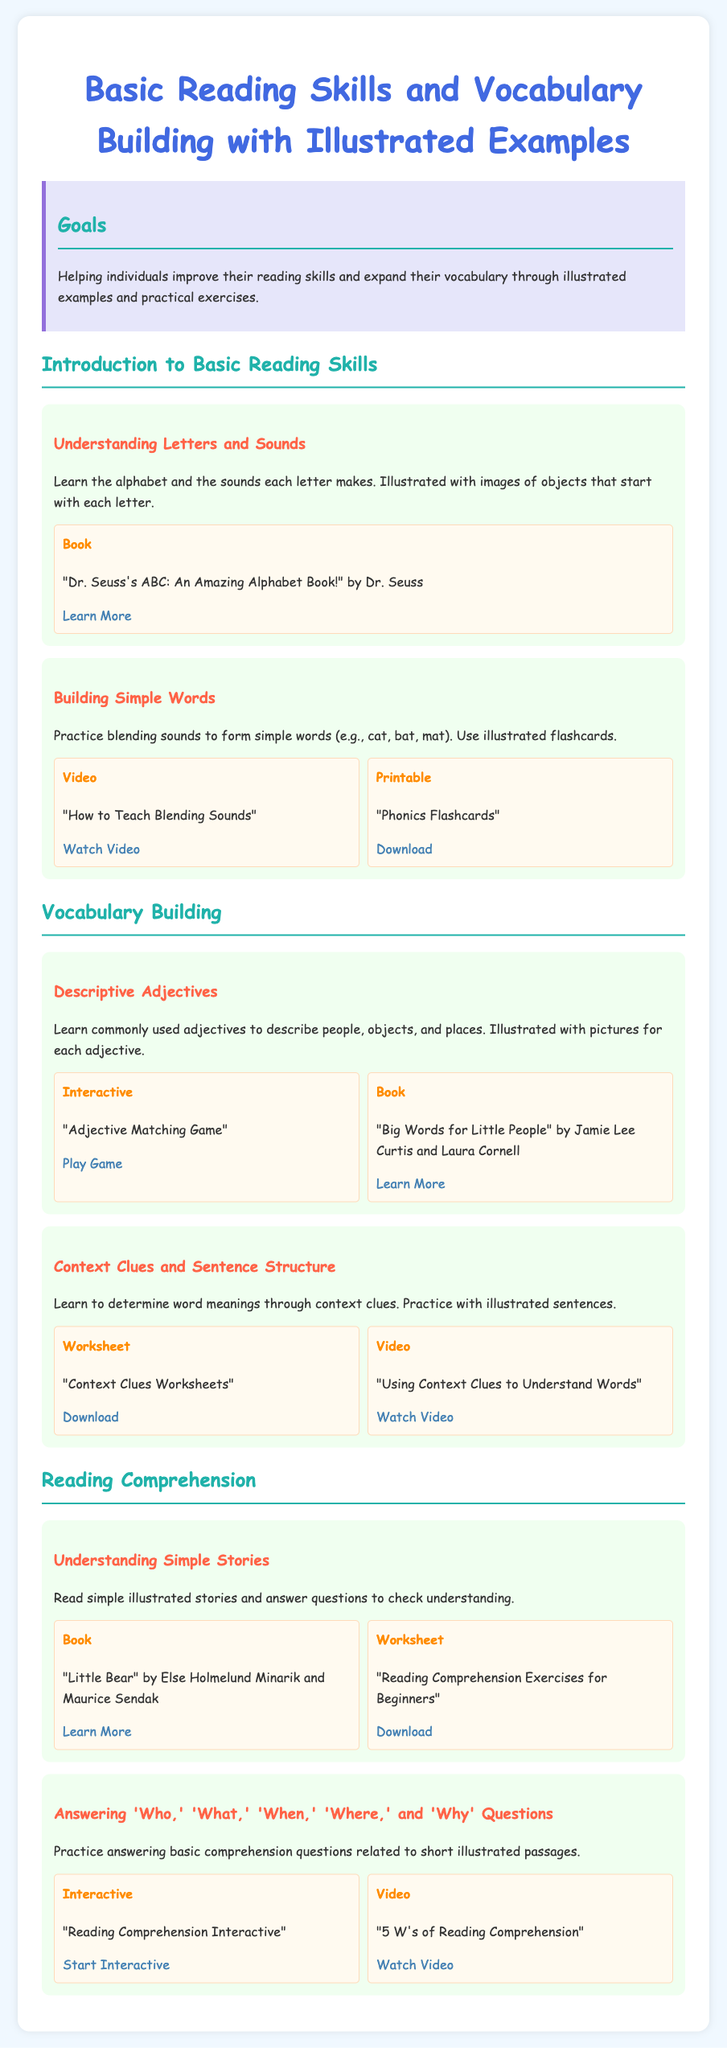what is the title of the document? The title is stated clearly in the header of the document.
Answer: Basic Reading Skills and Vocabulary Building with Illustrated Examples what kind of game is suggested for practicing adjectives? The game mentioned in the document is aimed at enhancing vocabulary skills through matching, as illustrated in the resources.
Answer: Adjective Matching Game who is the author of the book listed for understanding letters and sounds? The author's name is included next to the title of the suggested book in the resources section.
Answer: Dr. Seuss how many sections are there in the syllabus? The document divides its content into different sections, which can be identified through the headings.
Answer: Three what is one type of resource provided in the Vocabulary Building section? The section lists various resources that offer different formats of learning materials related to adjectives.
Answer: Interactive what type of sentences do participants practice in the context clues section? The document informs participants about the type of sentences they will encounter when learning about context clues.
Answer: Illustrated sentences what video title is associated with blending sounds? The video title is provided to facilitate learning through visual interaction with phonics skills.
Answer: How to Teach Blending Sounds how are the goals of the syllabus described? The goals of the syllabus are clearly stated to help understand the purpose of the learning materials.
Answer: Helping individuals improve their reading skills and expand their vocabulary through illustrated examples and practical exercises what question types do students practice in the reading comprehension section? The document highlights the specific types of questions that can help enhance understanding of simple stories.
Answer: Who, What, When, Where, and Why questions 